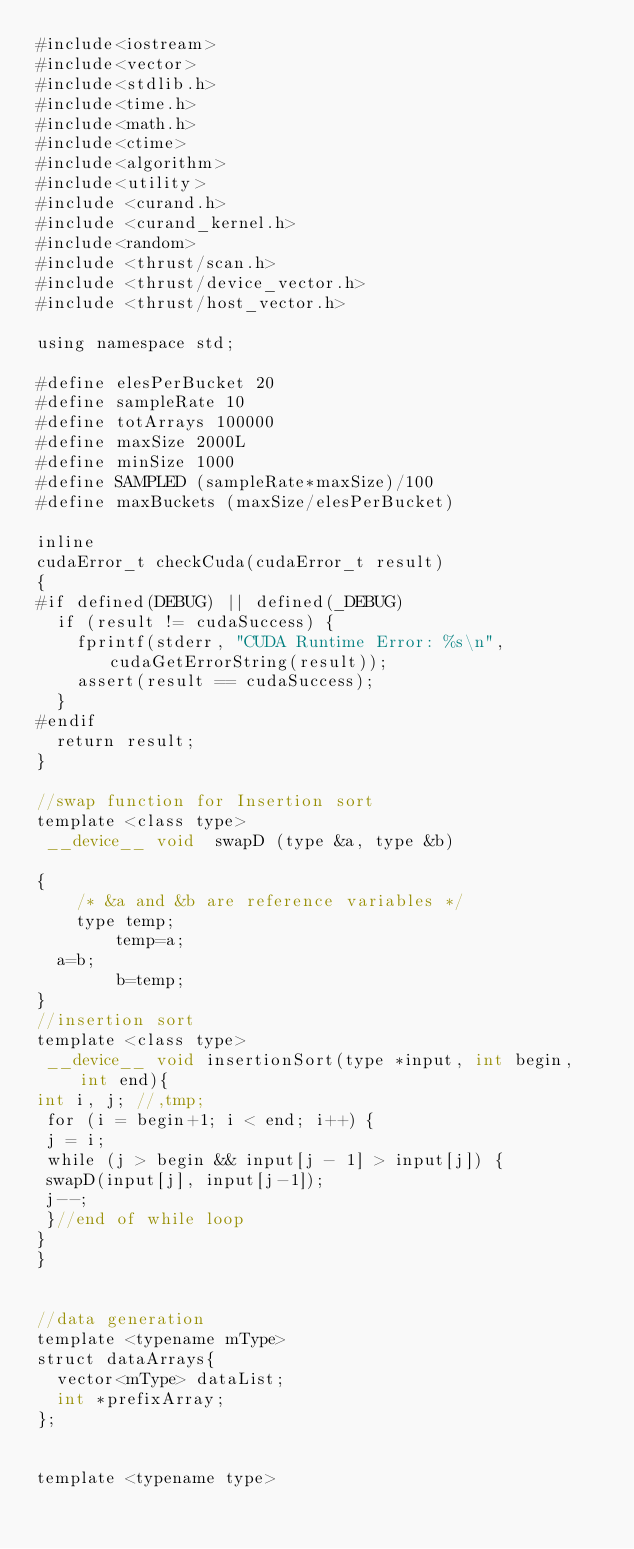Convert code to text. <code><loc_0><loc_0><loc_500><loc_500><_Cuda_>#include<iostream>
#include<vector>
#include<stdlib.h>
#include<time.h>
#include<math.h>
#include<ctime>
#include<algorithm>
#include<utility>
#include <curand.h>
#include <curand_kernel.h>
#include<random>
#include <thrust/scan.h>
#include <thrust/device_vector.h>
#include <thrust/host_vector.h>

using namespace std;

#define elesPerBucket 20
#define sampleRate 10
#define totArrays 100000
#define maxSize 2000L
#define minSize 1000
#define SAMPLED (sampleRate*maxSize)/100
#define maxBuckets (maxSize/elesPerBucket)

inline
cudaError_t checkCuda(cudaError_t result)
{
#if defined(DEBUG) || defined(_DEBUG)
  if (result != cudaSuccess) {
    fprintf(stderr, "CUDA Runtime Error: %s\n", cudaGetErrorString(result));
    assert(result == cudaSuccess);
  }
#endif
  return result;
}

//swap function for Insertion sort
template <class type>
 __device__ void  swapD (type &a, type &b)

{
    /* &a and &b are reference variables */
    type temp;
        temp=a;
	a=b;
        b=temp;
}
//insertion sort
template <class type>
 __device__ void insertionSort(type *input, int begin, int end){
int i, j; //,tmp;
 for (i = begin+1; i < end; i++) {
 j = i;
 while (j > begin && input[j - 1] > input[j]) {
 swapD(input[j], input[j-1]);
 j--;
 }//end of while loop
}
}


//data generation
template <typename mType>
struct dataArrays{
	vector<mType> dataList;
	int *prefixArray;
};


template <typename type> </code> 